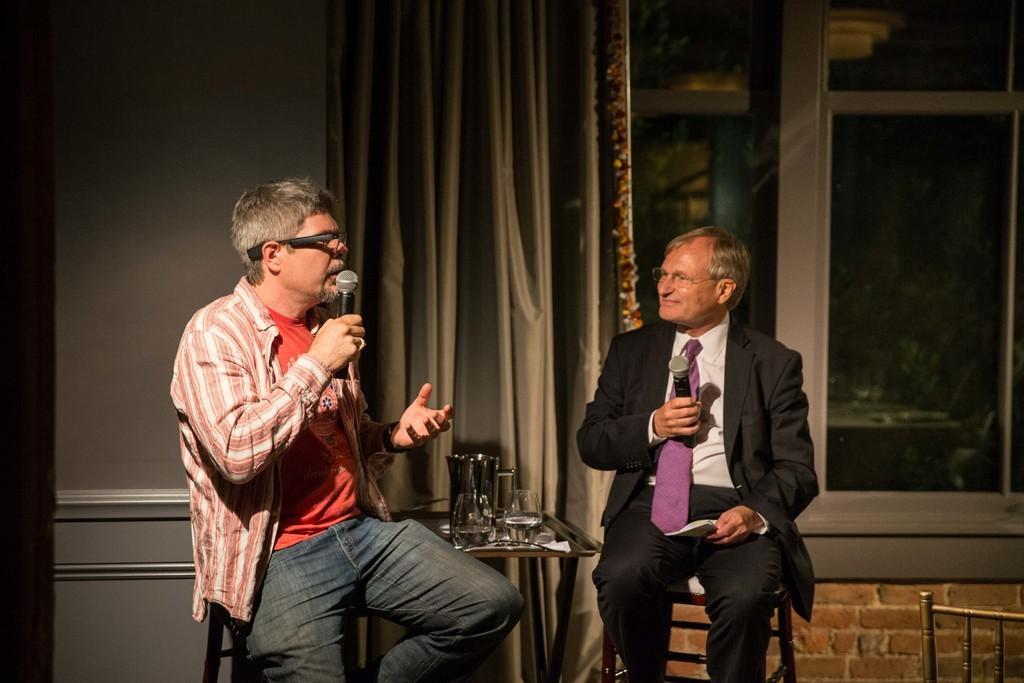Could you give a brief overview of what you see in this image? This image is taken indoors. In the background there is a wall with a window and there is a curtain. In the middle of the image there is a table with a few glasses and a few things on it. A man is sitting on a chair and he is holding a mic and a paper in his hands. Another man is sitting on the chair and he is holding a mic in his hand and talking. On the right side of the image there is an empty chair. 